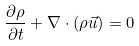<formula> <loc_0><loc_0><loc_500><loc_500>\frac { \partial \rho } { \partial t } + \nabla \cdot ( \rho \vec { u } ) = 0</formula> 